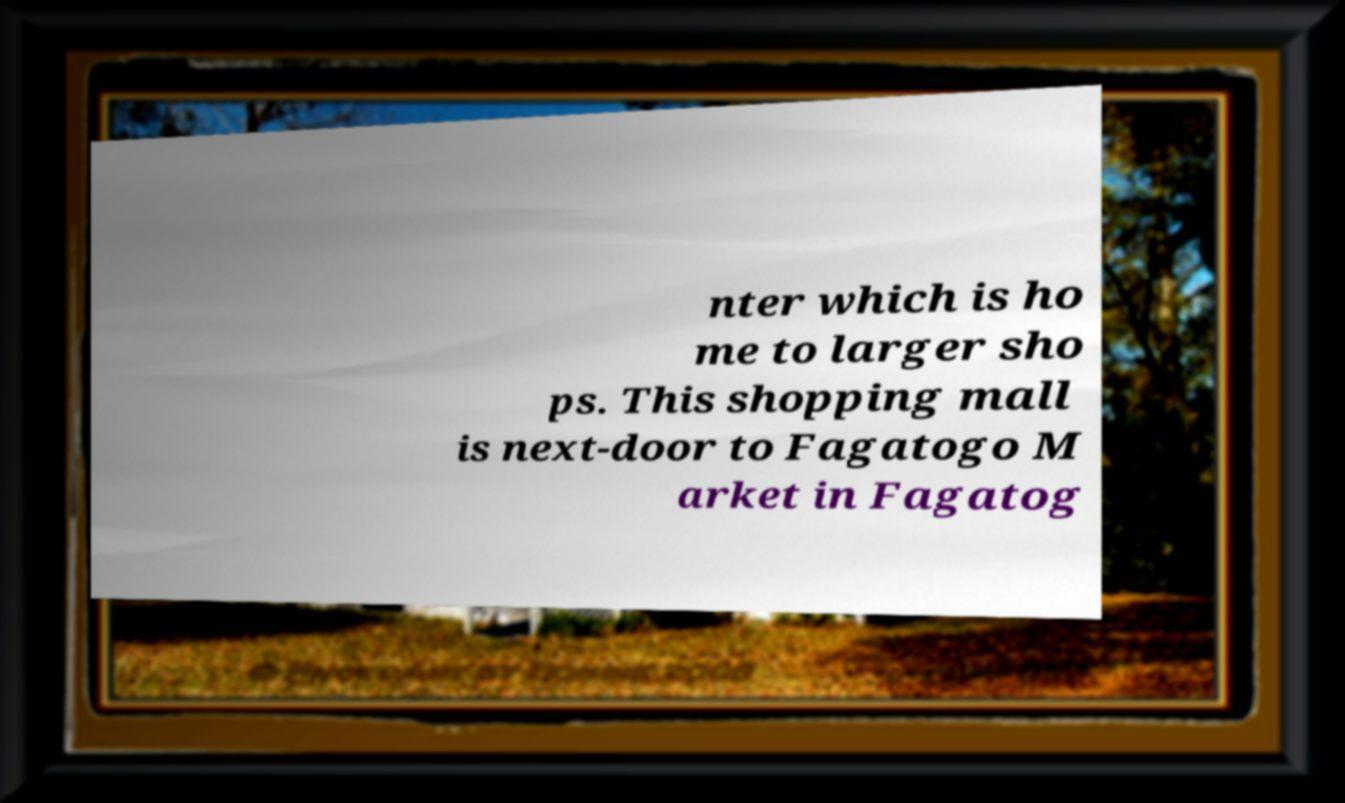Please read and relay the text visible in this image. What does it say? nter which is ho me to larger sho ps. This shopping mall is next-door to Fagatogo M arket in Fagatog 